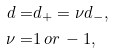<formula> <loc_0><loc_0><loc_500><loc_500>d = & d _ { + } = \nu d _ { - } , \\ \nu = & 1 \, o r \, - 1 ,</formula> 